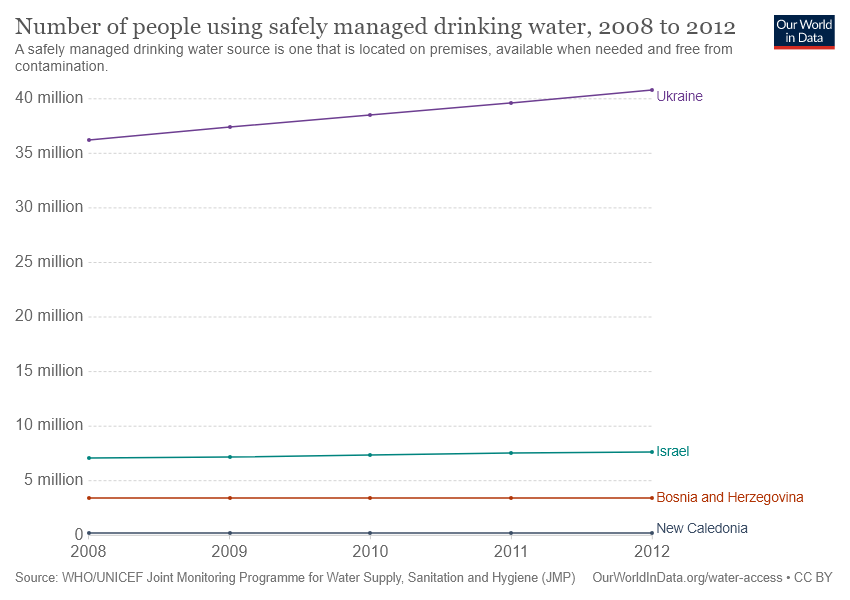Specify some key components in this picture. The value of Ukraine in 2012 was larger than the sum of the values of all other countries in that year. Four countries are included in this list. 